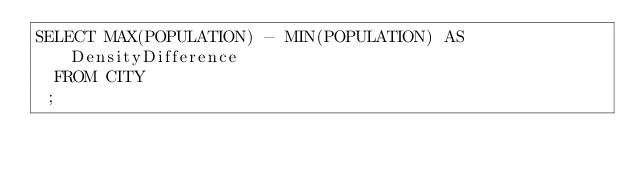Convert code to text. <code><loc_0><loc_0><loc_500><loc_500><_SQL_>SELECT MAX(POPULATION) - MIN(POPULATION) AS DensityDifference
  FROM CITY
 ;
</code> 